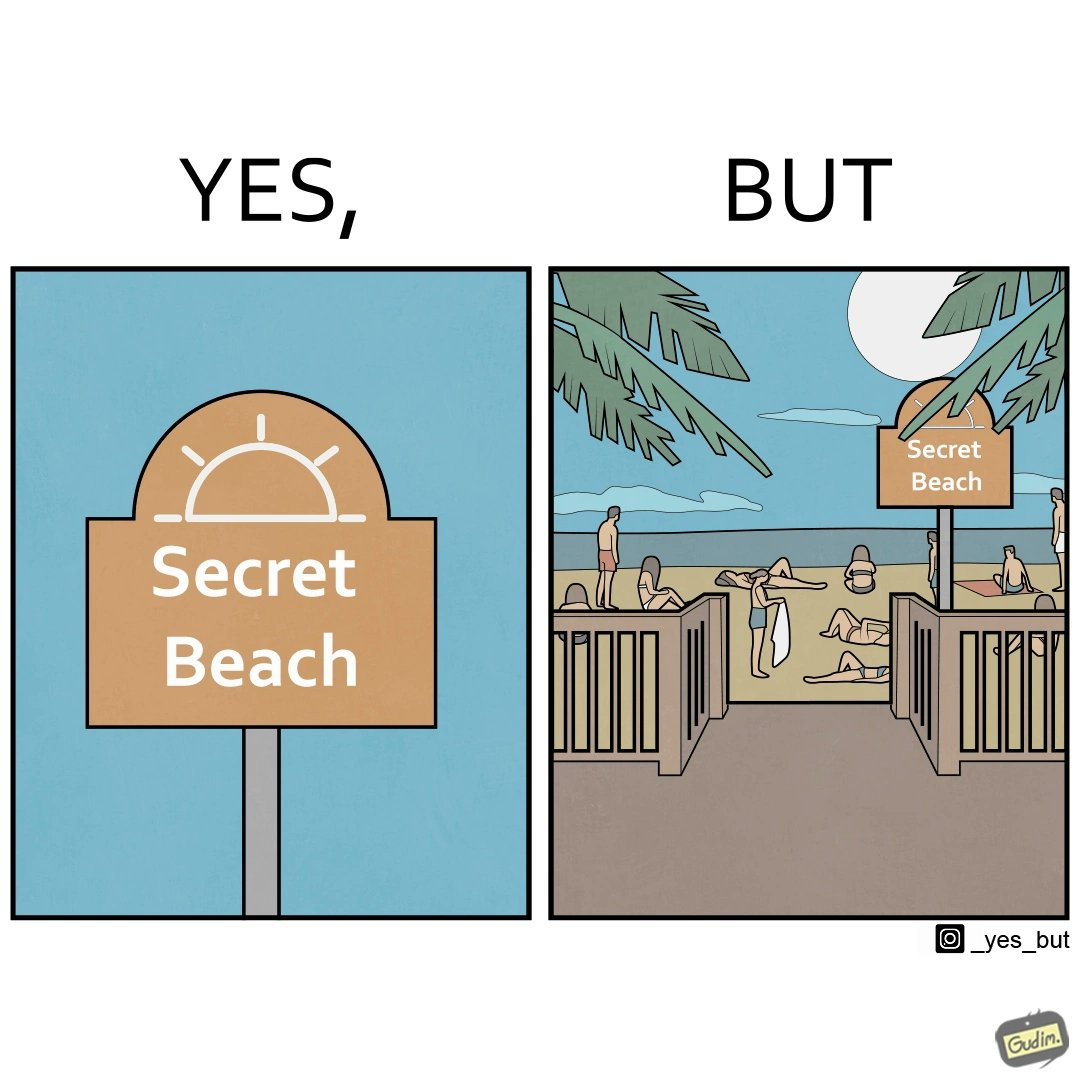What is the satirical meaning behind this image? The image is ironical, as people can be seen in the beach, and is clearly not a secret, while the board at the entrance has "Secret Beach" written on it. 